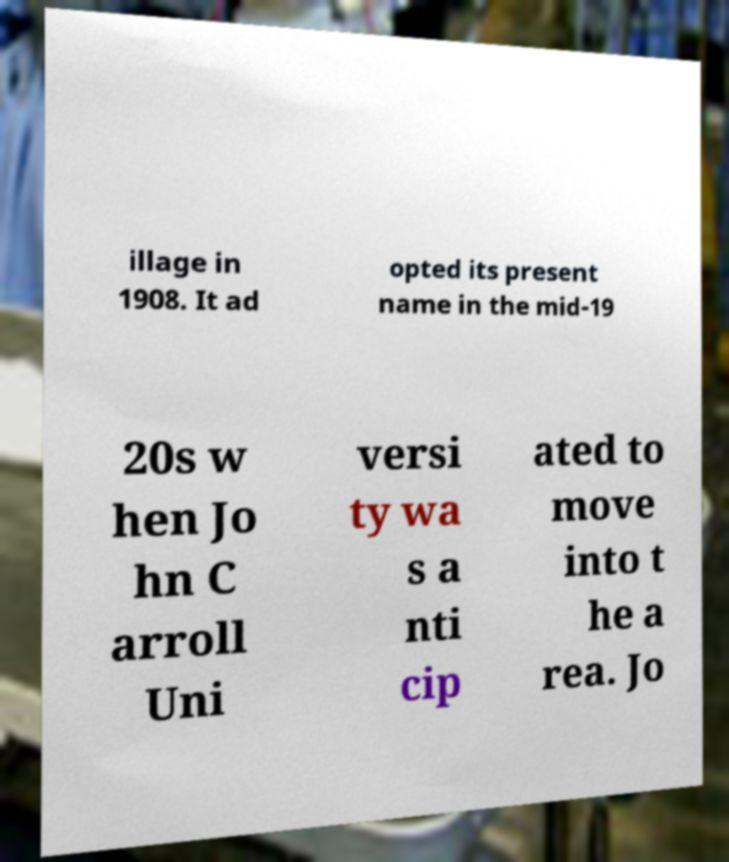Please read and relay the text visible in this image. What does it say? illage in 1908. It ad opted its present name in the mid-19 20s w hen Jo hn C arroll Uni versi ty wa s a nti cip ated to move into t he a rea. Jo 